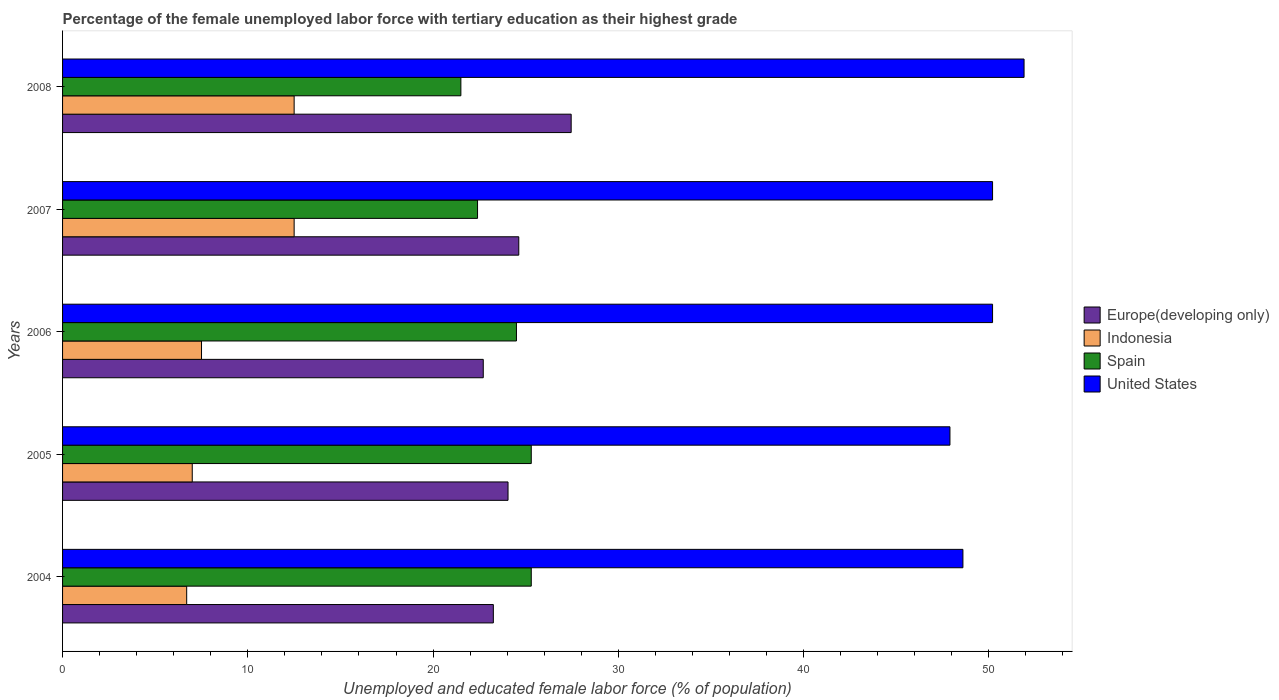Are the number of bars on each tick of the Y-axis equal?
Your response must be concise. Yes. How many bars are there on the 5th tick from the bottom?
Offer a terse response. 4. Across all years, what is the maximum percentage of the unemployed female labor force with tertiary education in Indonesia?
Your answer should be very brief. 12.5. Across all years, what is the minimum percentage of the unemployed female labor force with tertiary education in Indonesia?
Offer a very short reply. 6.7. What is the total percentage of the unemployed female labor force with tertiary education in Spain in the graph?
Give a very brief answer. 119. What is the difference between the percentage of the unemployed female labor force with tertiary education in Spain in 2006 and that in 2008?
Provide a short and direct response. 3. What is the difference between the percentage of the unemployed female labor force with tertiary education in United States in 2005 and the percentage of the unemployed female labor force with tertiary education in Spain in 2008?
Make the answer very short. 26.4. What is the average percentage of the unemployed female labor force with tertiary education in Indonesia per year?
Offer a very short reply. 9.24. In the year 2008, what is the difference between the percentage of the unemployed female labor force with tertiary education in United States and percentage of the unemployed female labor force with tertiary education in Indonesia?
Provide a succinct answer. 39.4. What is the ratio of the percentage of the unemployed female labor force with tertiary education in United States in 2004 to that in 2008?
Offer a terse response. 0.94. Is the difference between the percentage of the unemployed female labor force with tertiary education in United States in 2005 and 2007 greater than the difference between the percentage of the unemployed female labor force with tertiary education in Indonesia in 2005 and 2007?
Offer a terse response. Yes. What is the difference between the highest and the second highest percentage of the unemployed female labor force with tertiary education in Indonesia?
Make the answer very short. 0. In how many years, is the percentage of the unemployed female labor force with tertiary education in Europe(developing only) greater than the average percentage of the unemployed female labor force with tertiary education in Europe(developing only) taken over all years?
Your answer should be compact. 2. Is the sum of the percentage of the unemployed female labor force with tertiary education in United States in 2005 and 2008 greater than the maximum percentage of the unemployed female labor force with tertiary education in Indonesia across all years?
Offer a very short reply. Yes. Is it the case that in every year, the sum of the percentage of the unemployed female labor force with tertiary education in United States and percentage of the unemployed female labor force with tertiary education in Europe(developing only) is greater than the sum of percentage of the unemployed female labor force with tertiary education in Indonesia and percentage of the unemployed female labor force with tertiary education in Spain?
Your answer should be very brief. Yes. What does the 2nd bar from the top in 2006 represents?
Your response must be concise. Spain. Are all the bars in the graph horizontal?
Provide a short and direct response. Yes. What is the difference between two consecutive major ticks on the X-axis?
Your answer should be compact. 10. Does the graph contain any zero values?
Keep it short and to the point. No. How many legend labels are there?
Give a very brief answer. 4. How are the legend labels stacked?
Offer a very short reply. Vertical. What is the title of the graph?
Your response must be concise. Percentage of the female unemployed labor force with tertiary education as their highest grade. Does "Mongolia" appear as one of the legend labels in the graph?
Provide a short and direct response. No. What is the label or title of the X-axis?
Your answer should be very brief. Unemployed and educated female labor force (% of population). What is the Unemployed and educated female labor force (% of population) of Europe(developing only) in 2004?
Provide a short and direct response. 23.25. What is the Unemployed and educated female labor force (% of population) of Indonesia in 2004?
Ensure brevity in your answer.  6.7. What is the Unemployed and educated female labor force (% of population) of Spain in 2004?
Provide a short and direct response. 25.3. What is the Unemployed and educated female labor force (% of population) of United States in 2004?
Provide a short and direct response. 48.6. What is the Unemployed and educated female labor force (% of population) of Europe(developing only) in 2005?
Offer a terse response. 24.05. What is the Unemployed and educated female labor force (% of population) of Indonesia in 2005?
Your response must be concise. 7. What is the Unemployed and educated female labor force (% of population) of Spain in 2005?
Your answer should be compact. 25.3. What is the Unemployed and educated female labor force (% of population) in United States in 2005?
Give a very brief answer. 47.9. What is the Unemployed and educated female labor force (% of population) in Europe(developing only) in 2006?
Give a very brief answer. 22.71. What is the Unemployed and educated female labor force (% of population) in Indonesia in 2006?
Provide a succinct answer. 7.5. What is the Unemployed and educated female labor force (% of population) of United States in 2006?
Offer a very short reply. 50.2. What is the Unemployed and educated female labor force (% of population) in Europe(developing only) in 2007?
Keep it short and to the point. 24.63. What is the Unemployed and educated female labor force (% of population) in Spain in 2007?
Ensure brevity in your answer.  22.4. What is the Unemployed and educated female labor force (% of population) in United States in 2007?
Ensure brevity in your answer.  50.2. What is the Unemployed and educated female labor force (% of population) in Europe(developing only) in 2008?
Your answer should be compact. 27.45. What is the Unemployed and educated female labor force (% of population) of Indonesia in 2008?
Offer a terse response. 12.5. What is the Unemployed and educated female labor force (% of population) of Spain in 2008?
Your response must be concise. 21.5. What is the Unemployed and educated female labor force (% of population) of United States in 2008?
Your response must be concise. 51.9. Across all years, what is the maximum Unemployed and educated female labor force (% of population) in Europe(developing only)?
Your answer should be compact. 27.45. Across all years, what is the maximum Unemployed and educated female labor force (% of population) in Spain?
Provide a short and direct response. 25.3. Across all years, what is the maximum Unemployed and educated female labor force (% of population) of United States?
Provide a succinct answer. 51.9. Across all years, what is the minimum Unemployed and educated female labor force (% of population) of Europe(developing only)?
Offer a terse response. 22.71. Across all years, what is the minimum Unemployed and educated female labor force (% of population) in Indonesia?
Make the answer very short. 6.7. Across all years, what is the minimum Unemployed and educated female labor force (% of population) of United States?
Your response must be concise. 47.9. What is the total Unemployed and educated female labor force (% of population) of Europe(developing only) in the graph?
Your answer should be very brief. 122.09. What is the total Unemployed and educated female labor force (% of population) in Indonesia in the graph?
Make the answer very short. 46.2. What is the total Unemployed and educated female labor force (% of population) in Spain in the graph?
Keep it short and to the point. 119. What is the total Unemployed and educated female labor force (% of population) in United States in the graph?
Offer a very short reply. 248.8. What is the difference between the Unemployed and educated female labor force (% of population) in Europe(developing only) in 2004 and that in 2005?
Your response must be concise. -0.79. What is the difference between the Unemployed and educated female labor force (% of population) of Indonesia in 2004 and that in 2005?
Give a very brief answer. -0.3. What is the difference between the Unemployed and educated female labor force (% of population) in Spain in 2004 and that in 2005?
Your response must be concise. 0. What is the difference between the Unemployed and educated female labor force (% of population) of United States in 2004 and that in 2005?
Keep it short and to the point. 0.7. What is the difference between the Unemployed and educated female labor force (% of population) in Europe(developing only) in 2004 and that in 2006?
Keep it short and to the point. 0.54. What is the difference between the Unemployed and educated female labor force (% of population) of Spain in 2004 and that in 2006?
Your answer should be compact. 0.8. What is the difference between the Unemployed and educated female labor force (% of population) of United States in 2004 and that in 2006?
Provide a succinct answer. -1.6. What is the difference between the Unemployed and educated female labor force (% of population) in Europe(developing only) in 2004 and that in 2007?
Your answer should be compact. -1.37. What is the difference between the Unemployed and educated female labor force (% of population) of Indonesia in 2004 and that in 2007?
Your response must be concise. -5.8. What is the difference between the Unemployed and educated female labor force (% of population) in Europe(developing only) in 2004 and that in 2008?
Provide a succinct answer. -4.2. What is the difference between the Unemployed and educated female labor force (% of population) of United States in 2004 and that in 2008?
Your answer should be compact. -3.3. What is the difference between the Unemployed and educated female labor force (% of population) in Europe(developing only) in 2005 and that in 2006?
Give a very brief answer. 1.34. What is the difference between the Unemployed and educated female labor force (% of population) in Europe(developing only) in 2005 and that in 2007?
Give a very brief answer. -0.58. What is the difference between the Unemployed and educated female labor force (% of population) of Indonesia in 2005 and that in 2007?
Provide a short and direct response. -5.5. What is the difference between the Unemployed and educated female labor force (% of population) in United States in 2005 and that in 2007?
Your answer should be very brief. -2.3. What is the difference between the Unemployed and educated female labor force (% of population) of Europe(developing only) in 2005 and that in 2008?
Keep it short and to the point. -3.41. What is the difference between the Unemployed and educated female labor force (% of population) in Europe(developing only) in 2006 and that in 2007?
Your response must be concise. -1.92. What is the difference between the Unemployed and educated female labor force (% of population) in United States in 2006 and that in 2007?
Ensure brevity in your answer.  0. What is the difference between the Unemployed and educated female labor force (% of population) in Europe(developing only) in 2006 and that in 2008?
Your answer should be very brief. -4.75. What is the difference between the Unemployed and educated female labor force (% of population) of Indonesia in 2006 and that in 2008?
Keep it short and to the point. -5. What is the difference between the Unemployed and educated female labor force (% of population) of Spain in 2006 and that in 2008?
Offer a very short reply. 3. What is the difference between the Unemployed and educated female labor force (% of population) of United States in 2006 and that in 2008?
Offer a very short reply. -1.7. What is the difference between the Unemployed and educated female labor force (% of population) of Europe(developing only) in 2007 and that in 2008?
Provide a succinct answer. -2.83. What is the difference between the Unemployed and educated female labor force (% of population) of Europe(developing only) in 2004 and the Unemployed and educated female labor force (% of population) of Indonesia in 2005?
Offer a very short reply. 16.25. What is the difference between the Unemployed and educated female labor force (% of population) in Europe(developing only) in 2004 and the Unemployed and educated female labor force (% of population) in Spain in 2005?
Your answer should be very brief. -2.05. What is the difference between the Unemployed and educated female labor force (% of population) of Europe(developing only) in 2004 and the Unemployed and educated female labor force (% of population) of United States in 2005?
Make the answer very short. -24.65. What is the difference between the Unemployed and educated female labor force (% of population) of Indonesia in 2004 and the Unemployed and educated female labor force (% of population) of Spain in 2005?
Your answer should be very brief. -18.6. What is the difference between the Unemployed and educated female labor force (% of population) of Indonesia in 2004 and the Unemployed and educated female labor force (% of population) of United States in 2005?
Keep it short and to the point. -41.2. What is the difference between the Unemployed and educated female labor force (% of population) of Spain in 2004 and the Unemployed and educated female labor force (% of population) of United States in 2005?
Provide a succinct answer. -22.6. What is the difference between the Unemployed and educated female labor force (% of population) in Europe(developing only) in 2004 and the Unemployed and educated female labor force (% of population) in Indonesia in 2006?
Offer a very short reply. 15.75. What is the difference between the Unemployed and educated female labor force (% of population) in Europe(developing only) in 2004 and the Unemployed and educated female labor force (% of population) in Spain in 2006?
Ensure brevity in your answer.  -1.25. What is the difference between the Unemployed and educated female labor force (% of population) of Europe(developing only) in 2004 and the Unemployed and educated female labor force (% of population) of United States in 2006?
Your response must be concise. -26.95. What is the difference between the Unemployed and educated female labor force (% of population) of Indonesia in 2004 and the Unemployed and educated female labor force (% of population) of Spain in 2006?
Your answer should be compact. -17.8. What is the difference between the Unemployed and educated female labor force (% of population) in Indonesia in 2004 and the Unemployed and educated female labor force (% of population) in United States in 2006?
Make the answer very short. -43.5. What is the difference between the Unemployed and educated female labor force (% of population) in Spain in 2004 and the Unemployed and educated female labor force (% of population) in United States in 2006?
Your answer should be compact. -24.9. What is the difference between the Unemployed and educated female labor force (% of population) of Europe(developing only) in 2004 and the Unemployed and educated female labor force (% of population) of Indonesia in 2007?
Your answer should be compact. 10.75. What is the difference between the Unemployed and educated female labor force (% of population) of Europe(developing only) in 2004 and the Unemployed and educated female labor force (% of population) of Spain in 2007?
Your response must be concise. 0.85. What is the difference between the Unemployed and educated female labor force (% of population) in Europe(developing only) in 2004 and the Unemployed and educated female labor force (% of population) in United States in 2007?
Offer a very short reply. -26.95. What is the difference between the Unemployed and educated female labor force (% of population) in Indonesia in 2004 and the Unemployed and educated female labor force (% of population) in Spain in 2007?
Make the answer very short. -15.7. What is the difference between the Unemployed and educated female labor force (% of population) of Indonesia in 2004 and the Unemployed and educated female labor force (% of population) of United States in 2007?
Offer a terse response. -43.5. What is the difference between the Unemployed and educated female labor force (% of population) in Spain in 2004 and the Unemployed and educated female labor force (% of population) in United States in 2007?
Offer a very short reply. -24.9. What is the difference between the Unemployed and educated female labor force (% of population) in Europe(developing only) in 2004 and the Unemployed and educated female labor force (% of population) in Indonesia in 2008?
Provide a succinct answer. 10.75. What is the difference between the Unemployed and educated female labor force (% of population) of Europe(developing only) in 2004 and the Unemployed and educated female labor force (% of population) of Spain in 2008?
Keep it short and to the point. 1.75. What is the difference between the Unemployed and educated female labor force (% of population) of Europe(developing only) in 2004 and the Unemployed and educated female labor force (% of population) of United States in 2008?
Keep it short and to the point. -28.65. What is the difference between the Unemployed and educated female labor force (% of population) of Indonesia in 2004 and the Unemployed and educated female labor force (% of population) of Spain in 2008?
Give a very brief answer. -14.8. What is the difference between the Unemployed and educated female labor force (% of population) in Indonesia in 2004 and the Unemployed and educated female labor force (% of population) in United States in 2008?
Your response must be concise. -45.2. What is the difference between the Unemployed and educated female labor force (% of population) of Spain in 2004 and the Unemployed and educated female labor force (% of population) of United States in 2008?
Your answer should be very brief. -26.6. What is the difference between the Unemployed and educated female labor force (% of population) in Europe(developing only) in 2005 and the Unemployed and educated female labor force (% of population) in Indonesia in 2006?
Offer a very short reply. 16.55. What is the difference between the Unemployed and educated female labor force (% of population) of Europe(developing only) in 2005 and the Unemployed and educated female labor force (% of population) of Spain in 2006?
Your answer should be compact. -0.45. What is the difference between the Unemployed and educated female labor force (% of population) in Europe(developing only) in 2005 and the Unemployed and educated female labor force (% of population) in United States in 2006?
Ensure brevity in your answer.  -26.15. What is the difference between the Unemployed and educated female labor force (% of population) of Indonesia in 2005 and the Unemployed and educated female labor force (% of population) of Spain in 2006?
Give a very brief answer. -17.5. What is the difference between the Unemployed and educated female labor force (% of population) of Indonesia in 2005 and the Unemployed and educated female labor force (% of population) of United States in 2006?
Your answer should be very brief. -43.2. What is the difference between the Unemployed and educated female labor force (% of population) of Spain in 2005 and the Unemployed and educated female labor force (% of population) of United States in 2006?
Give a very brief answer. -24.9. What is the difference between the Unemployed and educated female labor force (% of population) of Europe(developing only) in 2005 and the Unemployed and educated female labor force (% of population) of Indonesia in 2007?
Your answer should be very brief. 11.55. What is the difference between the Unemployed and educated female labor force (% of population) of Europe(developing only) in 2005 and the Unemployed and educated female labor force (% of population) of Spain in 2007?
Your response must be concise. 1.65. What is the difference between the Unemployed and educated female labor force (% of population) of Europe(developing only) in 2005 and the Unemployed and educated female labor force (% of population) of United States in 2007?
Offer a terse response. -26.15. What is the difference between the Unemployed and educated female labor force (% of population) in Indonesia in 2005 and the Unemployed and educated female labor force (% of population) in Spain in 2007?
Offer a very short reply. -15.4. What is the difference between the Unemployed and educated female labor force (% of population) of Indonesia in 2005 and the Unemployed and educated female labor force (% of population) of United States in 2007?
Your response must be concise. -43.2. What is the difference between the Unemployed and educated female labor force (% of population) in Spain in 2005 and the Unemployed and educated female labor force (% of population) in United States in 2007?
Make the answer very short. -24.9. What is the difference between the Unemployed and educated female labor force (% of population) of Europe(developing only) in 2005 and the Unemployed and educated female labor force (% of population) of Indonesia in 2008?
Offer a very short reply. 11.55. What is the difference between the Unemployed and educated female labor force (% of population) in Europe(developing only) in 2005 and the Unemployed and educated female labor force (% of population) in Spain in 2008?
Keep it short and to the point. 2.55. What is the difference between the Unemployed and educated female labor force (% of population) of Europe(developing only) in 2005 and the Unemployed and educated female labor force (% of population) of United States in 2008?
Provide a succinct answer. -27.85. What is the difference between the Unemployed and educated female labor force (% of population) in Indonesia in 2005 and the Unemployed and educated female labor force (% of population) in United States in 2008?
Ensure brevity in your answer.  -44.9. What is the difference between the Unemployed and educated female labor force (% of population) of Spain in 2005 and the Unemployed and educated female labor force (% of population) of United States in 2008?
Make the answer very short. -26.6. What is the difference between the Unemployed and educated female labor force (% of population) in Europe(developing only) in 2006 and the Unemployed and educated female labor force (% of population) in Indonesia in 2007?
Offer a terse response. 10.21. What is the difference between the Unemployed and educated female labor force (% of population) in Europe(developing only) in 2006 and the Unemployed and educated female labor force (% of population) in Spain in 2007?
Your answer should be very brief. 0.31. What is the difference between the Unemployed and educated female labor force (% of population) in Europe(developing only) in 2006 and the Unemployed and educated female labor force (% of population) in United States in 2007?
Provide a succinct answer. -27.49. What is the difference between the Unemployed and educated female labor force (% of population) of Indonesia in 2006 and the Unemployed and educated female labor force (% of population) of Spain in 2007?
Provide a succinct answer. -14.9. What is the difference between the Unemployed and educated female labor force (% of population) in Indonesia in 2006 and the Unemployed and educated female labor force (% of population) in United States in 2007?
Ensure brevity in your answer.  -42.7. What is the difference between the Unemployed and educated female labor force (% of population) of Spain in 2006 and the Unemployed and educated female labor force (% of population) of United States in 2007?
Keep it short and to the point. -25.7. What is the difference between the Unemployed and educated female labor force (% of population) in Europe(developing only) in 2006 and the Unemployed and educated female labor force (% of population) in Indonesia in 2008?
Make the answer very short. 10.21. What is the difference between the Unemployed and educated female labor force (% of population) of Europe(developing only) in 2006 and the Unemployed and educated female labor force (% of population) of Spain in 2008?
Your answer should be compact. 1.21. What is the difference between the Unemployed and educated female labor force (% of population) in Europe(developing only) in 2006 and the Unemployed and educated female labor force (% of population) in United States in 2008?
Provide a short and direct response. -29.19. What is the difference between the Unemployed and educated female labor force (% of population) of Indonesia in 2006 and the Unemployed and educated female labor force (% of population) of Spain in 2008?
Provide a succinct answer. -14. What is the difference between the Unemployed and educated female labor force (% of population) of Indonesia in 2006 and the Unemployed and educated female labor force (% of population) of United States in 2008?
Your response must be concise. -44.4. What is the difference between the Unemployed and educated female labor force (% of population) in Spain in 2006 and the Unemployed and educated female labor force (% of population) in United States in 2008?
Provide a succinct answer. -27.4. What is the difference between the Unemployed and educated female labor force (% of population) of Europe(developing only) in 2007 and the Unemployed and educated female labor force (% of population) of Indonesia in 2008?
Keep it short and to the point. 12.13. What is the difference between the Unemployed and educated female labor force (% of population) in Europe(developing only) in 2007 and the Unemployed and educated female labor force (% of population) in Spain in 2008?
Offer a very short reply. 3.13. What is the difference between the Unemployed and educated female labor force (% of population) of Europe(developing only) in 2007 and the Unemployed and educated female labor force (% of population) of United States in 2008?
Make the answer very short. -27.27. What is the difference between the Unemployed and educated female labor force (% of population) in Indonesia in 2007 and the Unemployed and educated female labor force (% of population) in Spain in 2008?
Your response must be concise. -9. What is the difference between the Unemployed and educated female labor force (% of population) of Indonesia in 2007 and the Unemployed and educated female labor force (% of population) of United States in 2008?
Your answer should be very brief. -39.4. What is the difference between the Unemployed and educated female labor force (% of population) of Spain in 2007 and the Unemployed and educated female labor force (% of population) of United States in 2008?
Your answer should be compact. -29.5. What is the average Unemployed and educated female labor force (% of population) in Europe(developing only) per year?
Provide a succinct answer. 24.42. What is the average Unemployed and educated female labor force (% of population) in Indonesia per year?
Make the answer very short. 9.24. What is the average Unemployed and educated female labor force (% of population) in Spain per year?
Ensure brevity in your answer.  23.8. What is the average Unemployed and educated female labor force (% of population) in United States per year?
Ensure brevity in your answer.  49.76. In the year 2004, what is the difference between the Unemployed and educated female labor force (% of population) in Europe(developing only) and Unemployed and educated female labor force (% of population) in Indonesia?
Your answer should be compact. 16.55. In the year 2004, what is the difference between the Unemployed and educated female labor force (% of population) in Europe(developing only) and Unemployed and educated female labor force (% of population) in Spain?
Your answer should be compact. -2.05. In the year 2004, what is the difference between the Unemployed and educated female labor force (% of population) of Europe(developing only) and Unemployed and educated female labor force (% of population) of United States?
Provide a succinct answer. -25.35. In the year 2004, what is the difference between the Unemployed and educated female labor force (% of population) in Indonesia and Unemployed and educated female labor force (% of population) in Spain?
Give a very brief answer. -18.6. In the year 2004, what is the difference between the Unemployed and educated female labor force (% of population) in Indonesia and Unemployed and educated female labor force (% of population) in United States?
Provide a short and direct response. -41.9. In the year 2004, what is the difference between the Unemployed and educated female labor force (% of population) of Spain and Unemployed and educated female labor force (% of population) of United States?
Provide a short and direct response. -23.3. In the year 2005, what is the difference between the Unemployed and educated female labor force (% of population) of Europe(developing only) and Unemployed and educated female labor force (% of population) of Indonesia?
Your answer should be compact. 17.05. In the year 2005, what is the difference between the Unemployed and educated female labor force (% of population) of Europe(developing only) and Unemployed and educated female labor force (% of population) of Spain?
Provide a short and direct response. -1.25. In the year 2005, what is the difference between the Unemployed and educated female labor force (% of population) of Europe(developing only) and Unemployed and educated female labor force (% of population) of United States?
Your answer should be very brief. -23.85. In the year 2005, what is the difference between the Unemployed and educated female labor force (% of population) in Indonesia and Unemployed and educated female labor force (% of population) in Spain?
Provide a short and direct response. -18.3. In the year 2005, what is the difference between the Unemployed and educated female labor force (% of population) of Indonesia and Unemployed and educated female labor force (% of population) of United States?
Provide a short and direct response. -40.9. In the year 2005, what is the difference between the Unemployed and educated female labor force (% of population) in Spain and Unemployed and educated female labor force (% of population) in United States?
Make the answer very short. -22.6. In the year 2006, what is the difference between the Unemployed and educated female labor force (% of population) of Europe(developing only) and Unemployed and educated female labor force (% of population) of Indonesia?
Offer a terse response. 15.21. In the year 2006, what is the difference between the Unemployed and educated female labor force (% of population) of Europe(developing only) and Unemployed and educated female labor force (% of population) of Spain?
Offer a very short reply. -1.79. In the year 2006, what is the difference between the Unemployed and educated female labor force (% of population) of Europe(developing only) and Unemployed and educated female labor force (% of population) of United States?
Your answer should be compact. -27.49. In the year 2006, what is the difference between the Unemployed and educated female labor force (% of population) of Indonesia and Unemployed and educated female labor force (% of population) of United States?
Give a very brief answer. -42.7. In the year 2006, what is the difference between the Unemployed and educated female labor force (% of population) in Spain and Unemployed and educated female labor force (% of population) in United States?
Make the answer very short. -25.7. In the year 2007, what is the difference between the Unemployed and educated female labor force (% of population) of Europe(developing only) and Unemployed and educated female labor force (% of population) of Indonesia?
Ensure brevity in your answer.  12.13. In the year 2007, what is the difference between the Unemployed and educated female labor force (% of population) in Europe(developing only) and Unemployed and educated female labor force (% of population) in Spain?
Give a very brief answer. 2.23. In the year 2007, what is the difference between the Unemployed and educated female labor force (% of population) of Europe(developing only) and Unemployed and educated female labor force (% of population) of United States?
Your answer should be very brief. -25.57. In the year 2007, what is the difference between the Unemployed and educated female labor force (% of population) of Indonesia and Unemployed and educated female labor force (% of population) of Spain?
Provide a short and direct response. -9.9. In the year 2007, what is the difference between the Unemployed and educated female labor force (% of population) in Indonesia and Unemployed and educated female labor force (% of population) in United States?
Offer a terse response. -37.7. In the year 2007, what is the difference between the Unemployed and educated female labor force (% of population) in Spain and Unemployed and educated female labor force (% of population) in United States?
Ensure brevity in your answer.  -27.8. In the year 2008, what is the difference between the Unemployed and educated female labor force (% of population) in Europe(developing only) and Unemployed and educated female labor force (% of population) in Indonesia?
Offer a terse response. 14.95. In the year 2008, what is the difference between the Unemployed and educated female labor force (% of population) in Europe(developing only) and Unemployed and educated female labor force (% of population) in Spain?
Offer a very short reply. 5.95. In the year 2008, what is the difference between the Unemployed and educated female labor force (% of population) of Europe(developing only) and Unemployed and educated female labor force (% of population) of United States?
Your answer should be very brief. -24.45. In the year 2008, what is the difference between the Unemployed and educated female labor force (% of population) in Indonesia and Unemployed and educated female labor force (% of population) in United States?
Make the answer very short. -39.4. In the year 2008, what is the difference between the Unemployed and educated female labor force (% of population) in Spain and Unemployed and educated female labor force (% of population) in United States?
Keep it short and to the point. -30.4. What is the ratio of the Unemployed and educated female labor force (% of population) in Indonesia in 2004 to that in 2005?
Your response must be concise. 0.96. What is the ratio of the Unemployed and educated female labor force (% of population) of United States in 2004 to that in 2005?
Offer a very short reply. 1.01. What is the ratio of the Unemployed and educated female labor force (% of population) of Europe(developing only) in 2004 to that in 2006?
Your answer should be very brief. 1.02. What is the ratio of the Unemployed and educated female labor force (% of population) of Indonesia in 2004 to that in 2006?
Provide a succinct answer. 0.89. What is the ratio of the Unemployed and educated female labor force (% of population) of Spain in 2004 to that in 2006?
Ensure brevity in your answer.  1.03. What is the ratio of the Unemployed and educated female labor force (% of population) of United States in 2004 to that in 2006?
Give a very brief answer. 0.97. What is the ratio of the Unemployed and educated female labor force (% of population) of Europe(developing only) in 2004 to that in 2007?
Offer a very short reply. 0.94. What is the ratio of the Unemployed and educated female labor force (% of population) of Indonesia in 2004 to that in 2007?
Ensure brevity in your answer.  0.54. What is the ratio of the Unemployed and educated female labor force (% of population) of Spain in 2004 to that in 2007?
Offer a very short reply. 1.13. What is the ratio of the Unemployed and educated female labor force (% of population) in United States in 2004 to that in 2007?
Give a very brief answer. 0.97. What is the ratio of the Unemployed and educated female labor force (% of population) of Europe(developing only) in 2004 to that in 2008?
Your response must be concise. 0.85. What is the ratio of the Unemployed and educated female labor force (% of population) of Indonesia in 2004 to that in 2008?
Your answer should be compact. 0.54. What is the ratio of the Unemployed and educated female labor force (% of population) in Spain in 2004 to that in 2008?
Keep it short and to the point. 1.18. What is the ratio of the Unemployed and educated female labor force (% of population) in United States in 2004 to that in 2008?
Give a very brief answer. 0.94. What is the ratio of the Unemployed and educated female labor force (% of population) in Europe(developing only) in 2005 to that in 2006?
Your answer should be compact. 1.06. What is the ratio of the Unemployed and educated female labor force (% of population) of Indonesia in 2005 to that in 2006?
Provide a short and direct response. 0.93. What is the ratio of the Unemployed and educated female labor force (% of population) of Spain in 2005 to that in 2006?
Your answer should be compact. 1.03. What is the ratio of the Unemployed and educated female labor force (% of population) in United States in 2005 to that in 2006?
Offer a terse response. 0.95. What is the ratio of the Unemployed and educated female labor force (% of population) in Europe(developing only) in 2005 to that in 2007?
Offer a very short reply. 0.98. What is the ratio of the Unemployed and educated female labor force (% of population) in Indonesia in 2005 to that in 2007?
Offer a very short reply. 0.56. What is the ratio of the Unemployed and educated female labor force (% of population) in Spain in 2005 to that in 2007?
Make the answer very short. 1.13. What is the ratio of the Unemployed and educated female labor force (% of population) in United States in 2005 to that in 2007?
Your response must be concise. 0.95. What is the ratio of the Unemployed and educated female labor force (% of population) of Europe(developing only) in 2005 to that in 2008?
Your answer should be very brief. 0.88. What is the ratio of the Unemployed and educated female labor force (% of population) of Indonesia in 2005 to that in 2008?
Keep it short and to the point. 0.56. What is the ratio of the Unemployed and educated female labor force (% of population) in Spain in 2005 to that in 2008?
Make the answer very short. 1.18. What is the ratio of the Unemployed and educated female labor force (% of population) in United States in 2005 to that in 2008?
Your answer should be very brief. 0.92. What is the ratio of the Unemployed and educated female labor force (% of population) of Europe(developing only) in 2006 to that in 2007?
Make the answer very short. 0.92. What is the ratio of the Unemployed and educated female labor force (% of population) in Indonesia in 2006 to that in 2007?
Provide a short and direct response. 0.6. What is the ratio of the Unemployed and educated female labor force (% of population) in Spain in 2006 to that in 2007?
Your response must be concise. 1.09. What is the ratio of the Unemployed and educated female labor force (% of population) in Europe(developing only) in 2006 to that in 2008?
Provide a short and direct response. 0.83. What is the ratio of the Unemployed and educated female labor force (% of population) in Spain in 2006 to that in 2008?
Make the answer very short. 1.14. What is the ratio of the Unemployed and educated female labor force (% of population) in United States in 2006 to that in 2008?
Your response must be concise. 0.97. What is the ratio of the Unemployed and educated female labor force (% of population) of Europe(developing only) in 2007 to that in 2008?
Your response must be concise. 0.9. What is the ratio of the Unemployed and educated female labor force (% of population) of Spain in 2007 to that in 2008?
Your response must be concise. 1.04. What is the ratio of the Unemployed and educated female labor force (% of population) in United States in 2007 to that in 2008?
Keep it short and to the point. 0.97. What is the difference between the highest and the second highest Unemployed and educated female labor force (% of population) in Europe(developing only)?
Your answer should be compact. 2.83. What is the difference between the highest and the second highest Unemployed and educated female labor force (% of population) in Indonesia?
Provide a succinct answer. 0. What is the difference between the highest and the second highest Unemployed and educated female labor force (% of population) of United States?
Ensure brevity in your answer.  1.7. What is the difference between the highest and the lowest Unemployed and educated female labor force (% of population) of Europe(developing only)?
Give a very brief answer. 4.75. What is the difference between the highest and the lowest Unemployed and educated female labor force (% of population) in Indonesia?
Offer a very short reply. 5.8. What is the difference between the highest and the lowest Unemployed and educated female labor force (% of population) of Spain?
Provide a short and direct response. 3.8. What is the difference between the highest and the lowest Unemployed and educated female labor force (% of population) of United States?
Keep it short and to the point. 4. 